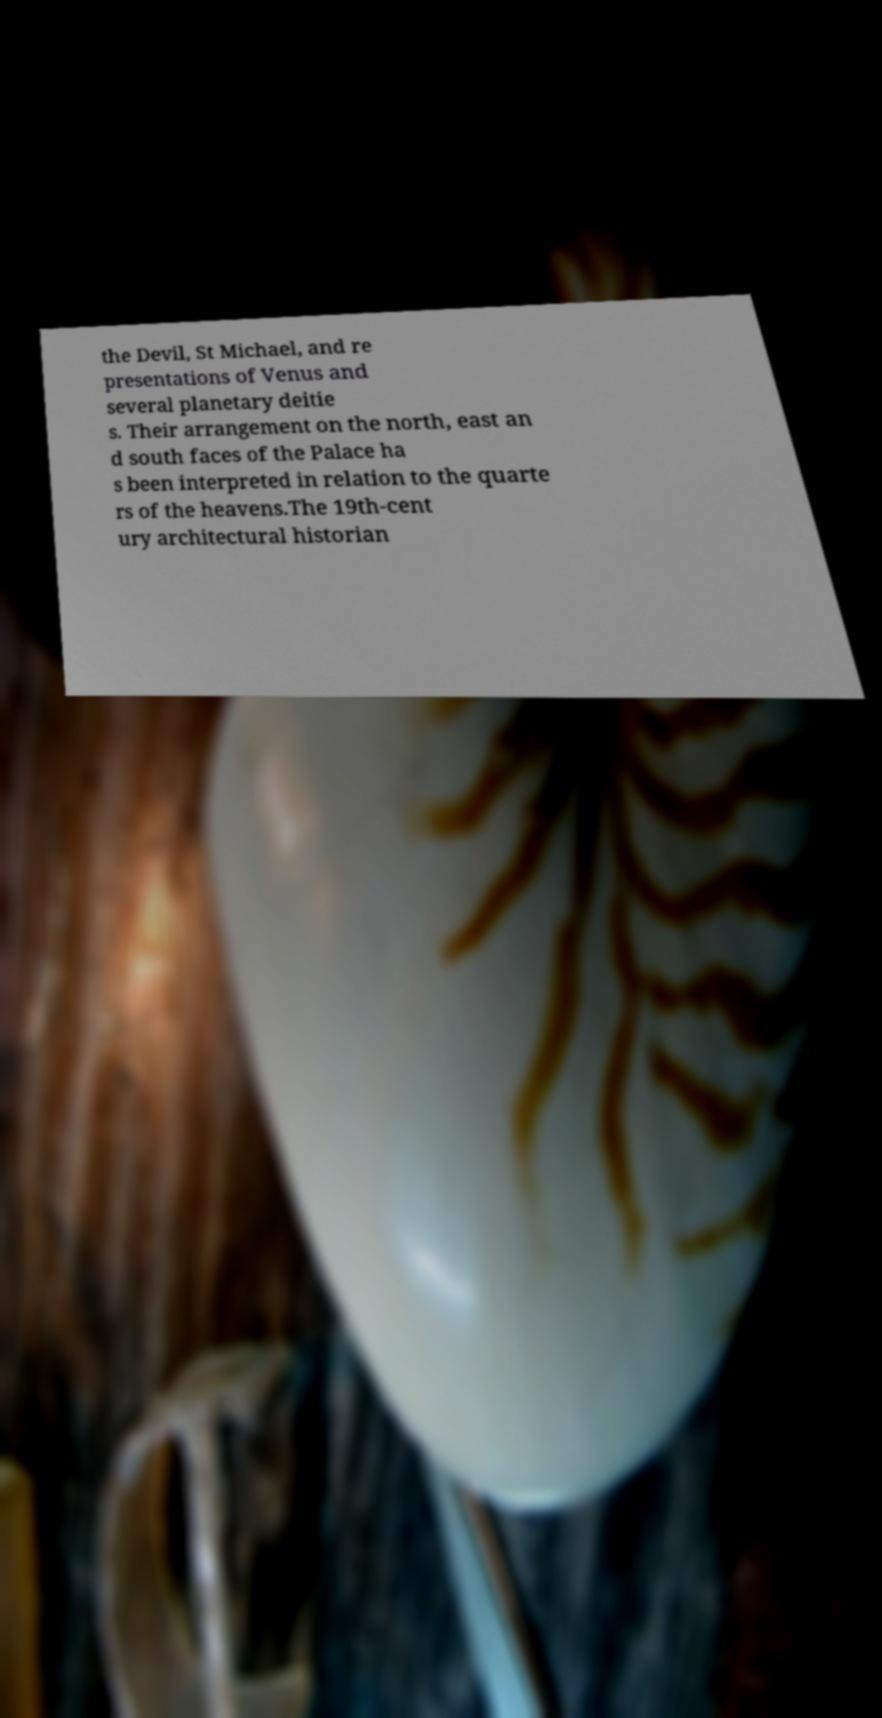What messages or text are displayed in this image? I need them in a readable, typed format. the Devil, St Michael, and re presentations of Venus and several planetary deitie s. Their arrangement on the north, east an d south faces of the Palace ha s been interpreted in relation to the quarte rs of the heavens.The 19th-cent ury architectural historian 